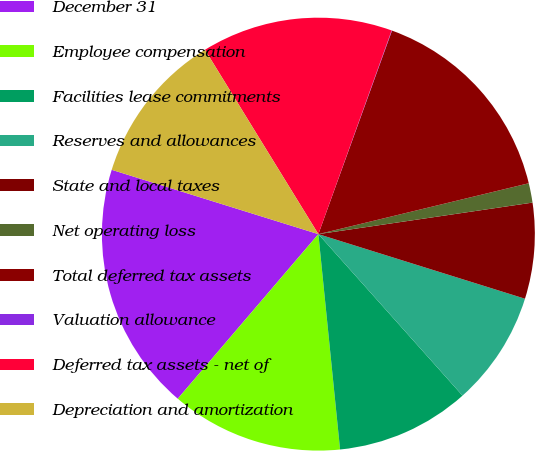Convert chart. <chart><loc_0><loc_0><loc_500><loc_500><pie_chart><fcel>December 31<fcel>Employee compensation<fcel>Facilities lease commitments<fcel>Reserves and allowances<fcel>State and local taxes<fcel>Net operating loss<fcel>Total deferred tax assets<fcel>Valuation allowance<fcel>Deferred tax assets - net of<fcel>Depreciation and amortization<nl><fcel>18.55%<fcel>12.85%<fcel>10.0%<fcel>8.58%<fcel>7.15%<fcel>1.45%<fcel>15.7%<fcel>0.03%<fcel>14.27%<fcel>11.42%<nl></chart> 